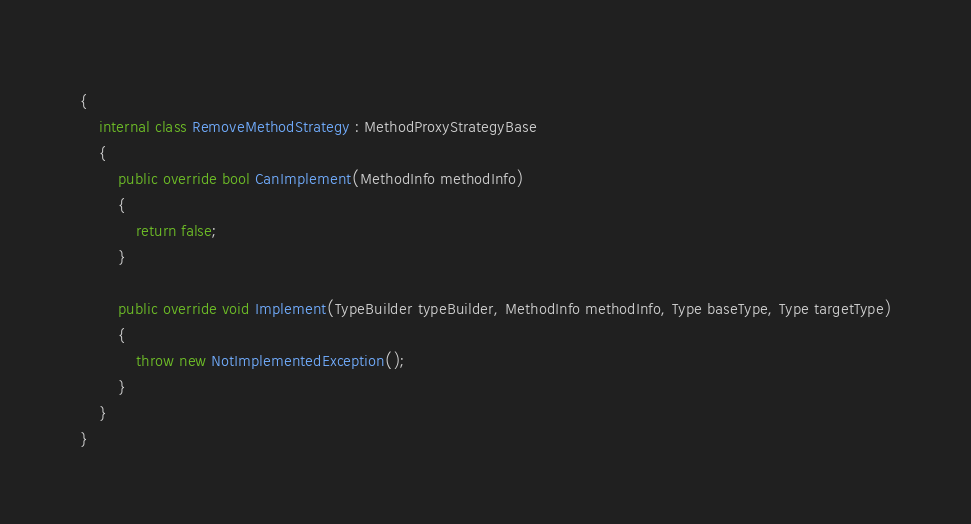<code> <loc_0><loc_0><loc_500><loc_500><_C#_>{
    internal class RemoveMethodStrategy : MethodProxyStrategyBase
    {
        public override bool CanImplement(MethodInfo methodInfo)
        {
            return false;
        }

        public override void Implement(TypeBuilder typeBuilder, MethodInfo methodInfo, Type baseType, Type targetType)
        {
            throw new NotImplementedException();
        }
    }
}
</code> 